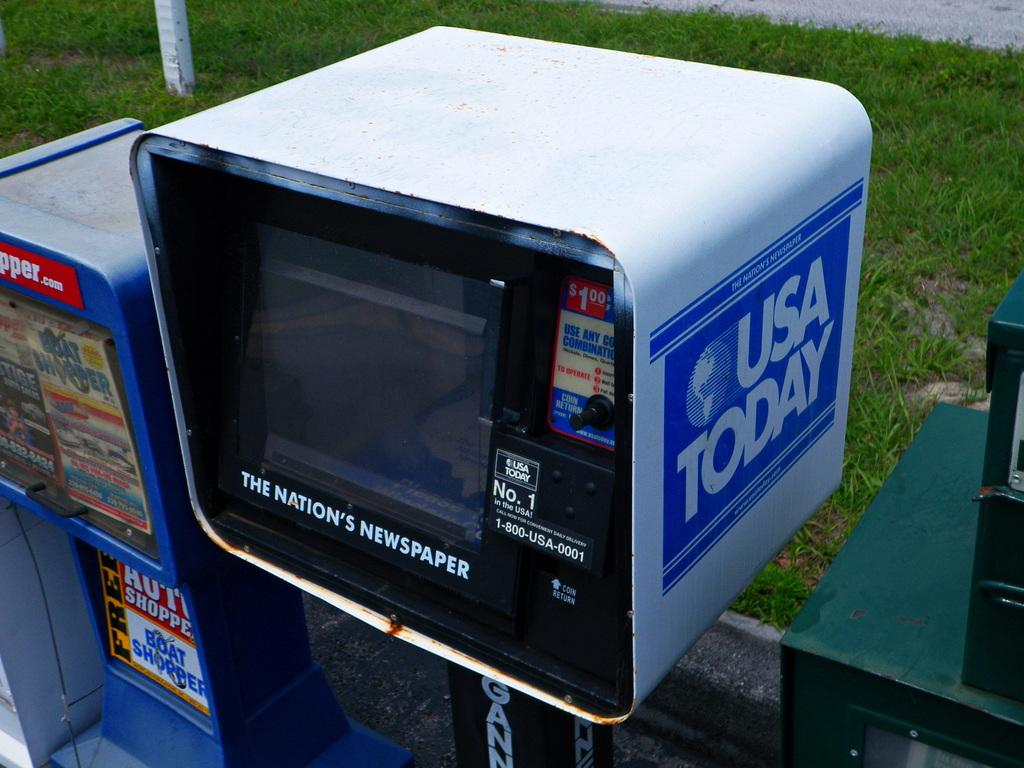<image>
Describe the image concisely. A USA Today newspaper vending machine is stands in front of a grass verge. 